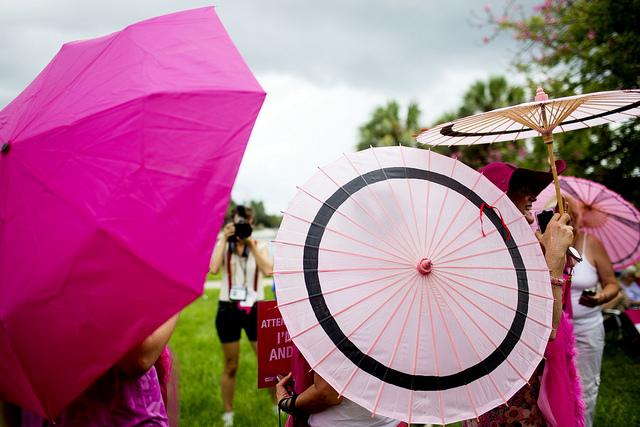Is picture taken looking upwards?
Give a very brief answer. No. What is the color of the umbrella?
Be succinct. Pink. Is it cloudy out?
Quick response, please. Yes. Are the pink umbrellas for rain?
Be succinct. No. Are any people holding the umbrellas?
Short answer required. Yes. How many umbrellas can be seen?
Short answer required. 4. How many umbrellas are shown?
Give a very brief answer. 4. 